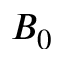Convert formula to latex. <formula><loc_0><loc_0><loc_500><loc_500>B _ { 0 }</formula> 